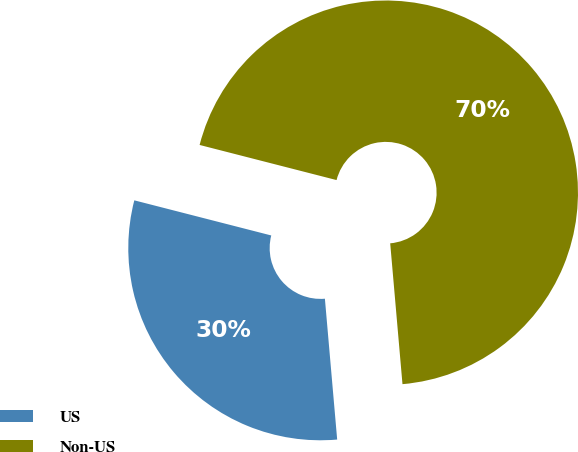<chart> <loc_0><loc_0><loc_500><loc_500><pie_chart><fcel>US<fcel>Non-US<nl><fcel>30.38%<fcel>69.62%<nl></chart> 